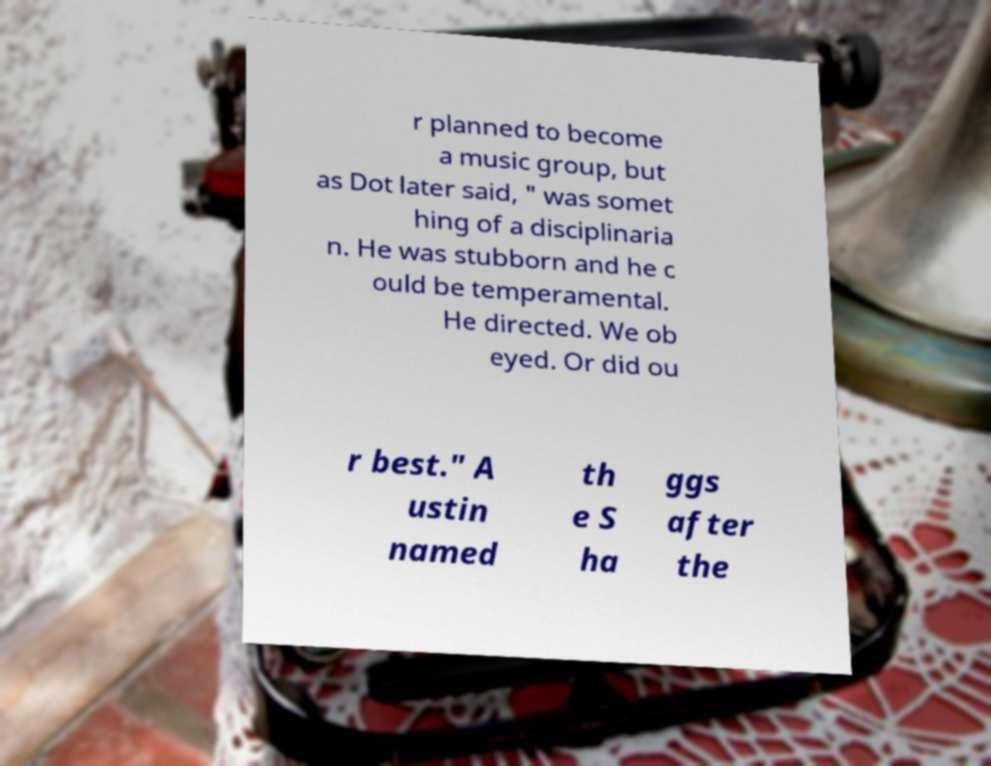Can you accurately transcribe the text from the provided image for me? r planned to become a music group, but as Dot later said, " was somet hing of a disciplinaria n. He was stubborn and he c ould be temperamental. He directed. We ob eyed. Or did ou r best." A ustin named th e S ha ggs after the 